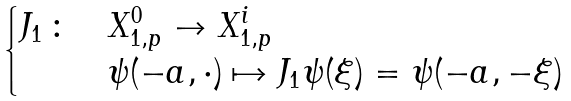Convert formula to latex. <formula><loc_0><loc_0><loc_500><loc_500>\begin{cases} J _ { 1 } \, \colon & X ^ { 0 } _ { 1 , p } \to X ^ { i } _ { 1 , p } \\ & \psi ( - a , \cdot ) \mapsto J _ { 1 } \psi ( \xi ) = \psi ( - a , - \xi ) \end{cases}</formula> 